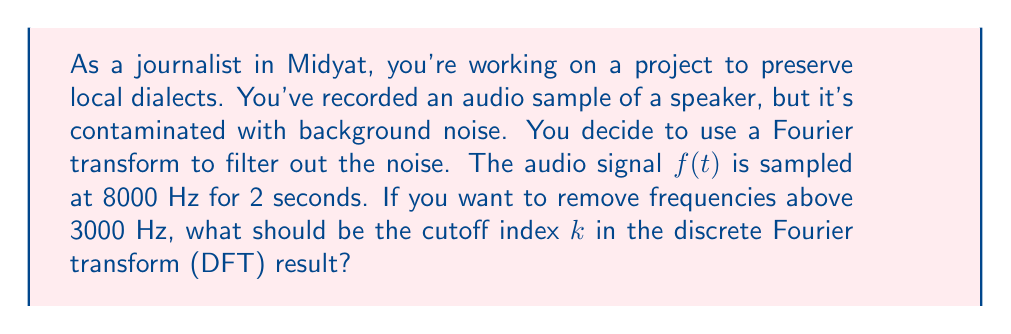Show me your answer to this math problem. To solve this problem, let's follow these steps:

1) First, let's calculate the total number of samples $N$:
   $N = \text{sampling rate} \times \text{duration} = 8000 \text{ Hz} \times 2 \text{ s} = 16000$ samples

2) In the DFT result, the frequency resolution $\Delta f$ is given by:
   $$\Delta f = \frac{\text{sampling rate}}{N} = \frac{8000 \text{ Hz}}{16000} = 0.5 \text{ Hz}$$

3) The relationship between the index $k$ in the DFT result and the corresponding frequency $f$ is:
   $$f = k \cdot \Delta f$$

4) We want to find the index $k$ that corresponds to 3000 Hz:
   $$3000 \text{ Hz} = k \cdot 0.5 \text{ Hz}$$

5) Solving for $k$:
   $$k = \frac{3000 \text{ Hz}}{0.5 \text{ Hz}} = 6000$$

6) Therefore, to remove frequencies above 3000 Hz, we should set all DFT coefficients with index greater than 6000 to zero.

Note: In practice, you would typically apply a smoother filter rather than a hard cutoff to avoid introducing artifacts in the audio signal.
Answer: $k = 6000$ 